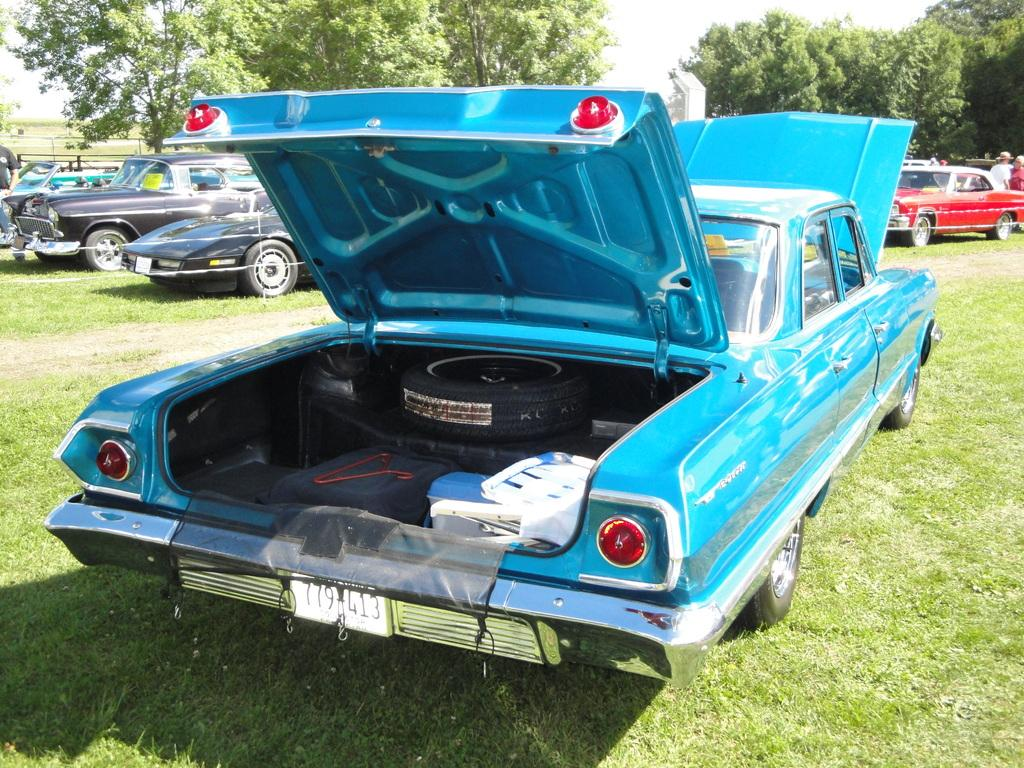What can be seen on the ground in the image? There are many vehicles on the ground in the image. What can be said about the appearance of the vehicles? The vehicles are colorful. Are there any people visible in the image? Yes, there are people visible near the vehicles. What is visible in the background of the image? There are many trees in the background of the image. How would you describe the sky in the image? The sky is white in the image. What type of cord is being used to tie the corn in the image? There is no cord or corn present in the image; it features many vehicles, people, trees, and a white sky. 